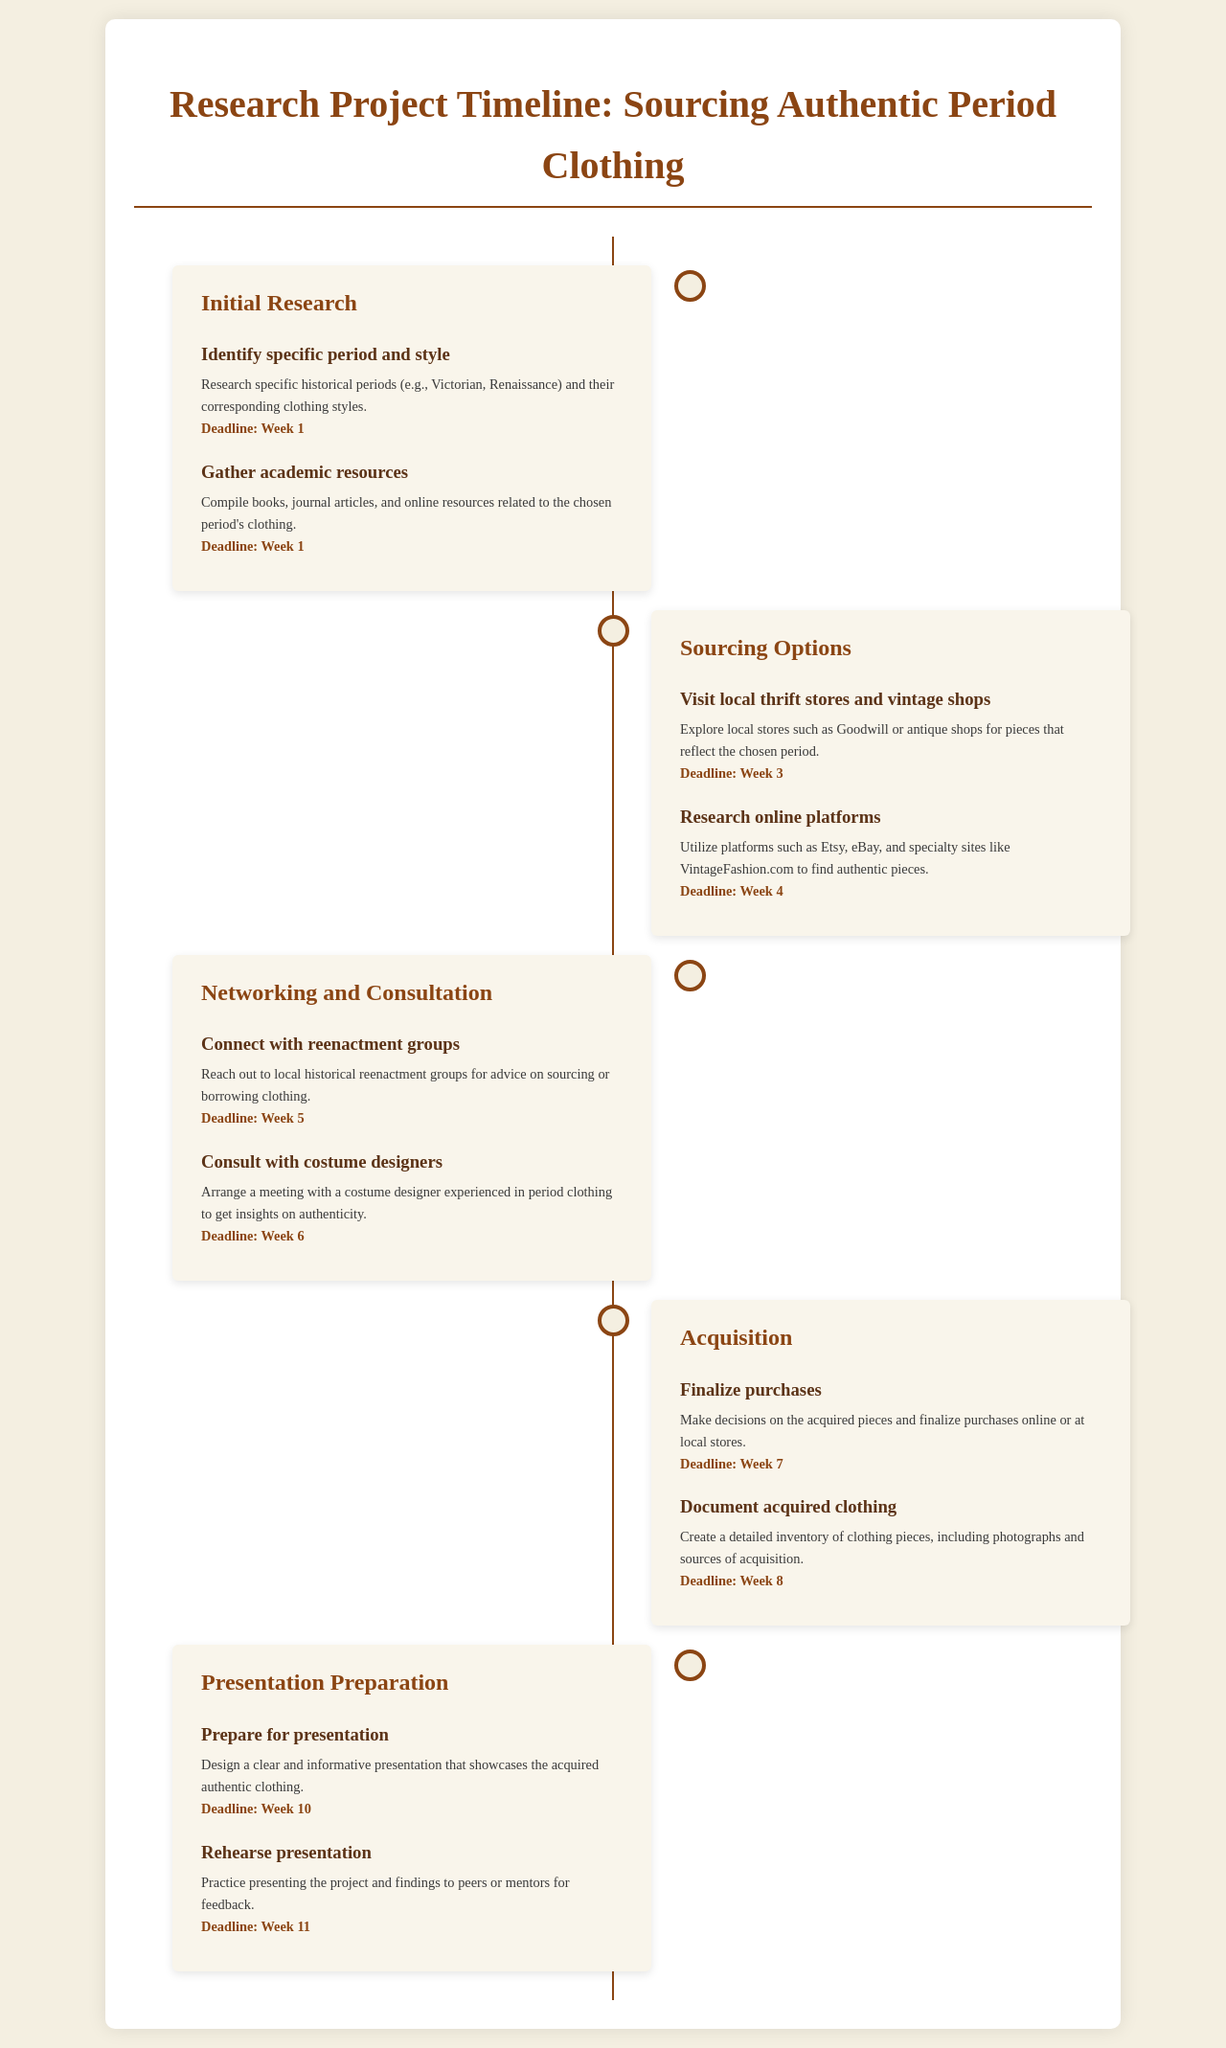what is the first task in the initial research phase? The first task is to identify specific period and style, which involves researching specific historical periods and clothing styles.
Answer: identify specific period and style what is the deadline for gathering academic resources? The deadline for gathering academic resources is outlined in the document, which specifies Week 1.
Answer: Week 1 which phase includes consulting with costume designers? The phase that includes consulting with costume designers is Networking and Consultation.
Answer: Networking and Consultation how many weeks are allocated for sourcing options? The sourcing options phase spans from Week 3 to Week 4, which covers two weeks.
Answer: 2 weeks what is the last activity in the acquisition phase? The last activity in the acquisition phase is to document acquired clothing.
Answer: Document acquired clothing when is the presentation preparation deadline? The deadline for preparing the presentation is given in the document as Week 10.
Answer: Week 10 how many activities are listed under the sourcing options phase? The document lists two activities under the sourcing options phase.
Answer: 2 activities what is the primary focus of the initial research phase? The primary focus is to identify specific historical periods and their corresponding clothing styles.
Answer: Identify specific historical periods and styles 